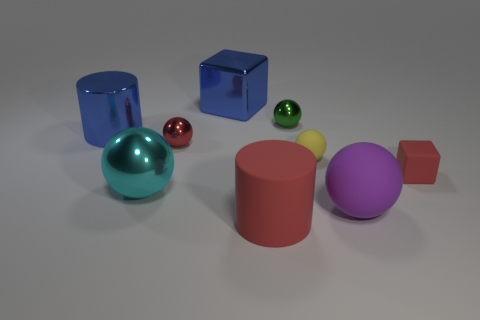Subtract all purple matte balls. How many balls are left? 4 Subtract all purple balls. How many balls are left? 4 Subtract all blue balls. Subtract all purple cylinders. How many balls are left? 5 Add 1 small cyan rubber things. How many objects exist? 10 Subtract all cylinders. How many objects are left? 7 Subtract 0 green cubes. How many objects are left? 9 Subtract all tiny purple metal blocks. Subtract all tiny yellow things. How many objects are left? 8 Add 9 big red rubber things. How many big red rubber things are left? 10 Add 3 small spheres. How many small spheres exist? 6 